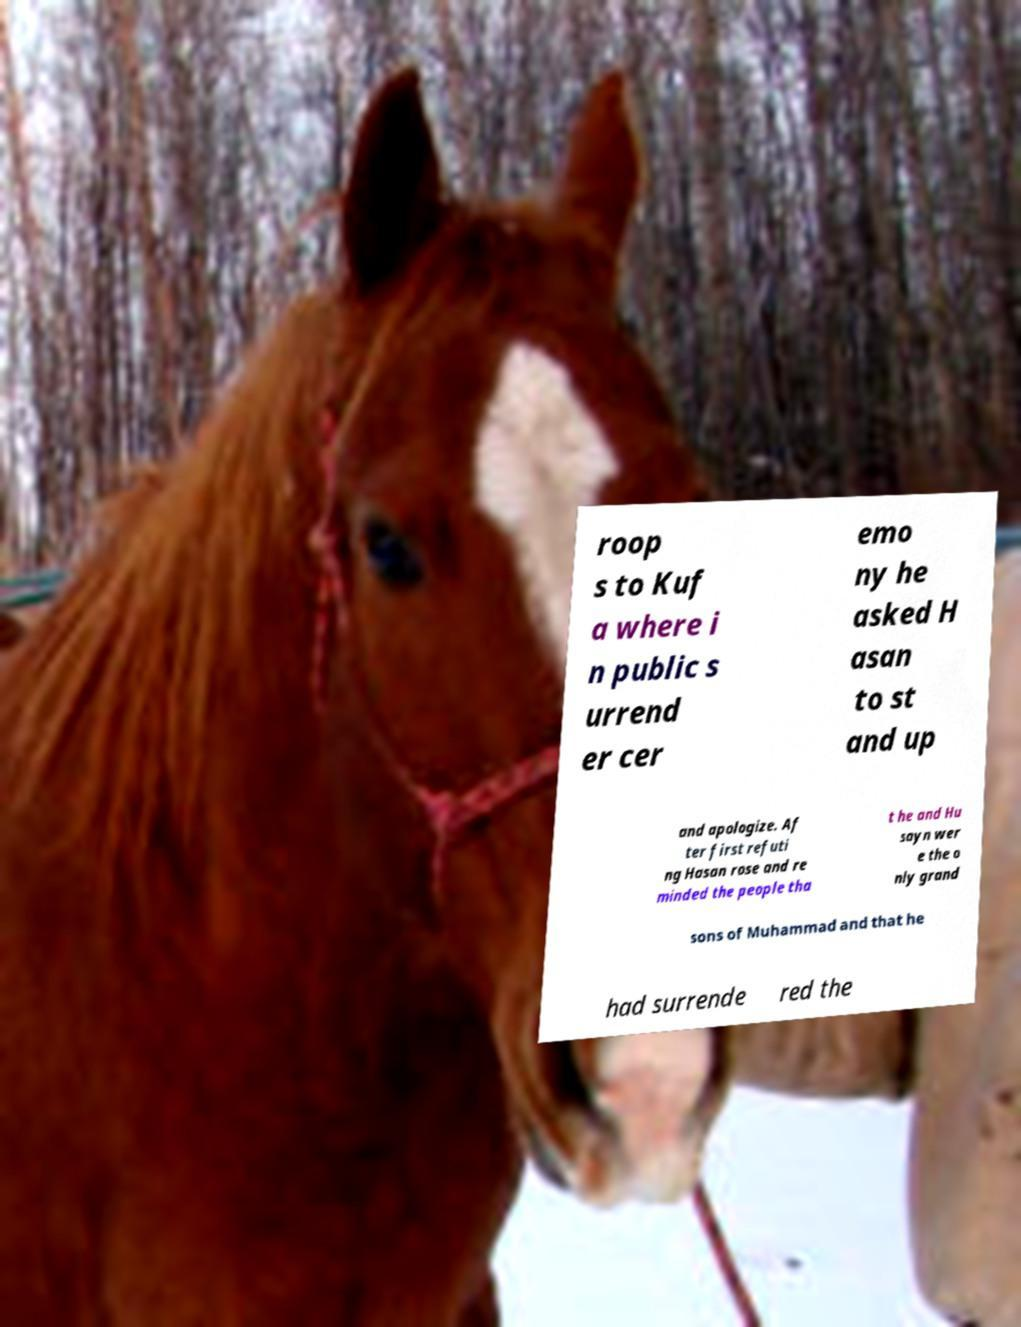There's text embedded in this image that I need extracted. Can you transcribe it verbatim? roop s to Kuf a where i n public s urrend er cer emo ny he asked H asan to st and up and apologize. Af ter first refuti ng Hasan rose and re minded the people tha t he and Hu sayn wer e the o nly grand sons of Muhammad and that he had surrende red the 